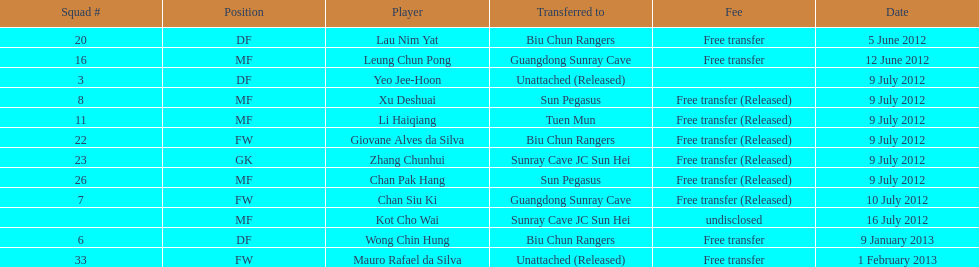What group # is positioned prior to group # 7? 26. Would you be able to parse every entry in this table? {'header': ['Squad #', 'Position', 'Player', 'Transferred to', 'Fee', 'Date'], 'rows': [['20', 'DF', 'Lau Nim Yat', 'Biu Chun Rangers', 'Free transfer', '5 June 2012'], ['16', 'MF', 'Leung Chun Pong', 'Guangdong Sunray Cave', 'Free transfer', '12 June 2012'], ['3', 'DF', 'Yeo Jee-Hoon', 'Unattached (Released)', '', '9 July 2012'], ['8', 'MF', 'Xu Deshuai', 'Sun Pegasus', 'Free transfer (Released)', '9 July 2012'], ['11', 'MF', 'Li Haiqiang', 'Tuen Mun', 'Free transfer (Released)', '9 July 2012'], ['22', 'FW', 'Giovane Alves da Silva', 'Biu Chun Rangers', 'Free transfer (Released)', '9 July 2012'], ['23', 'GK', 'Zhang Chunhui', 'Sunray Cave JC Sun Hei', 'Free transfer (Released)', '9 July 2012'], ['26', 'MF', 'Chan Pak Hang', 'Sun Pegasus', 'Free transfer (Released)', '9 July 2012'], ['7', 'FW', 'Chan Siu Ki', 'Guangdong Sunray Cave', 'Free transfer (Released)', '10 July 2012'], ['', 'MF', 'Kot Cho Wai', 'Sunray Cave JC Sun Hei', 'undisclosed', '16 July 2012'], ['6', 'DF', 'Wong Chin Hung', 'Biu Chun Rangers', 'Free transfer', '9 January 2013'], ['33', 'FW', 'Mauro Rafael da Silva', 'Unattached (Released)', 'Free transfer', '1 February 2013']]} 